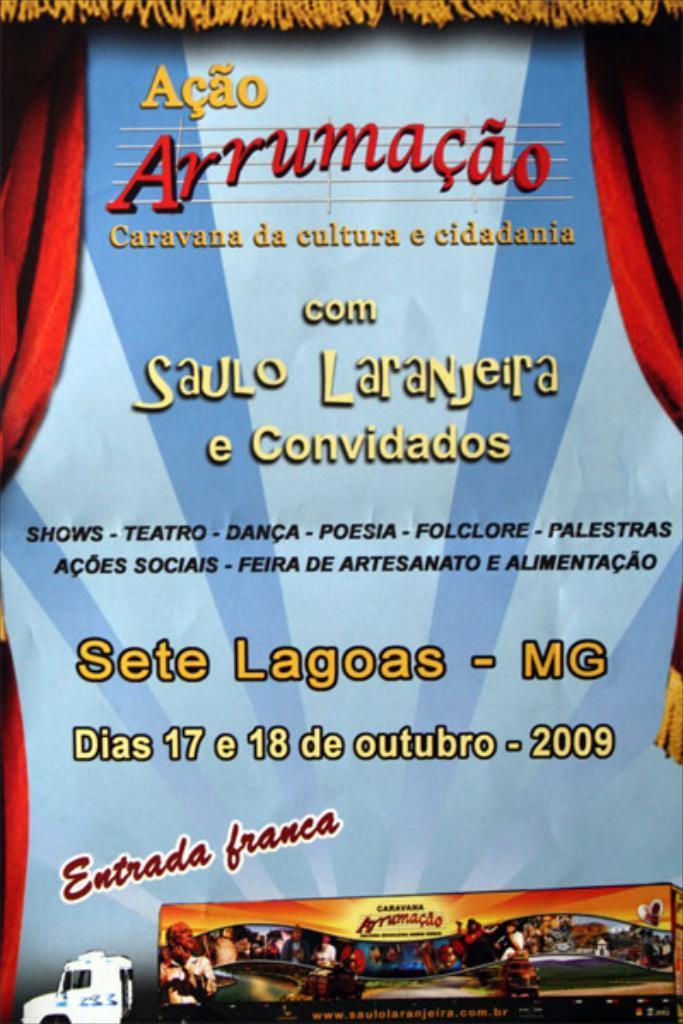Describe this image in one or two sentences. In this image we can see a poster. We can see a vehicle and there is a banner on the container of it. We can see few people on the banner. There are few curtains in the image. There is some text on the poster. 